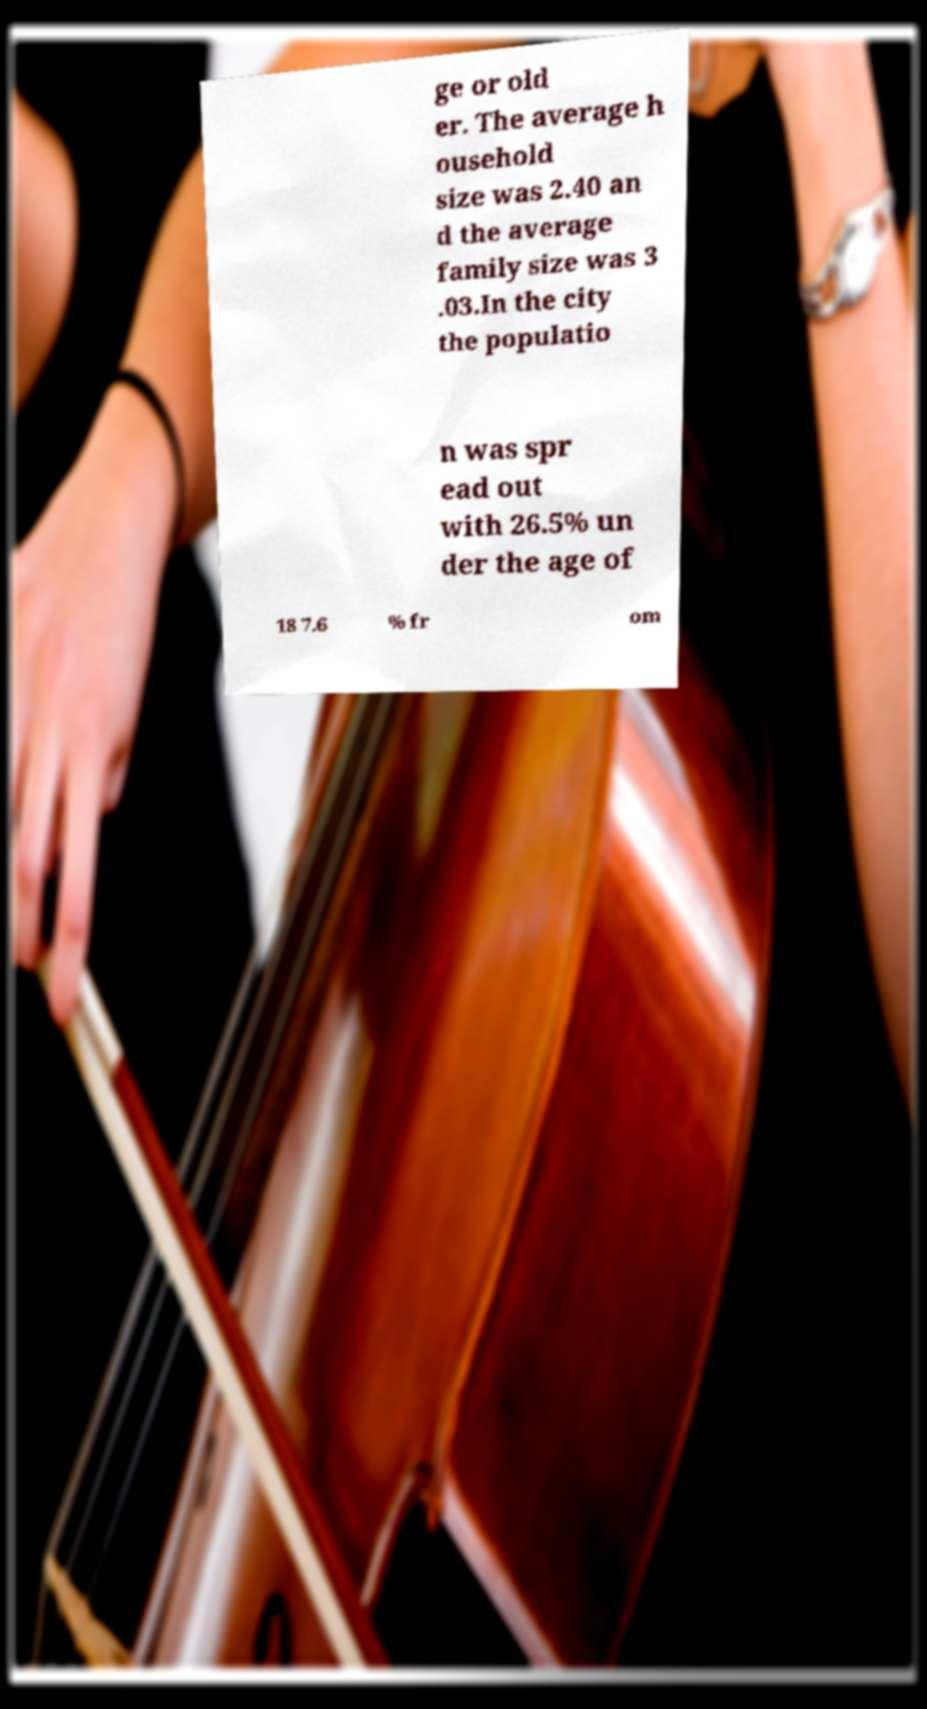Can you accurately transcribe the text from the provided image for me? ge or old er. The average h ousehold size was 2.40 an d the average family size was 3 .03.In the city the populatio n was spr ead out with 26.5% un der the age of 18 7.6 % fr om 